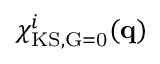<formula> <loc_0><loc_0><loc_500><loc_500>\chi _ { K S , \vec { G } = 0 } ^ { i } ( q )</formula> 